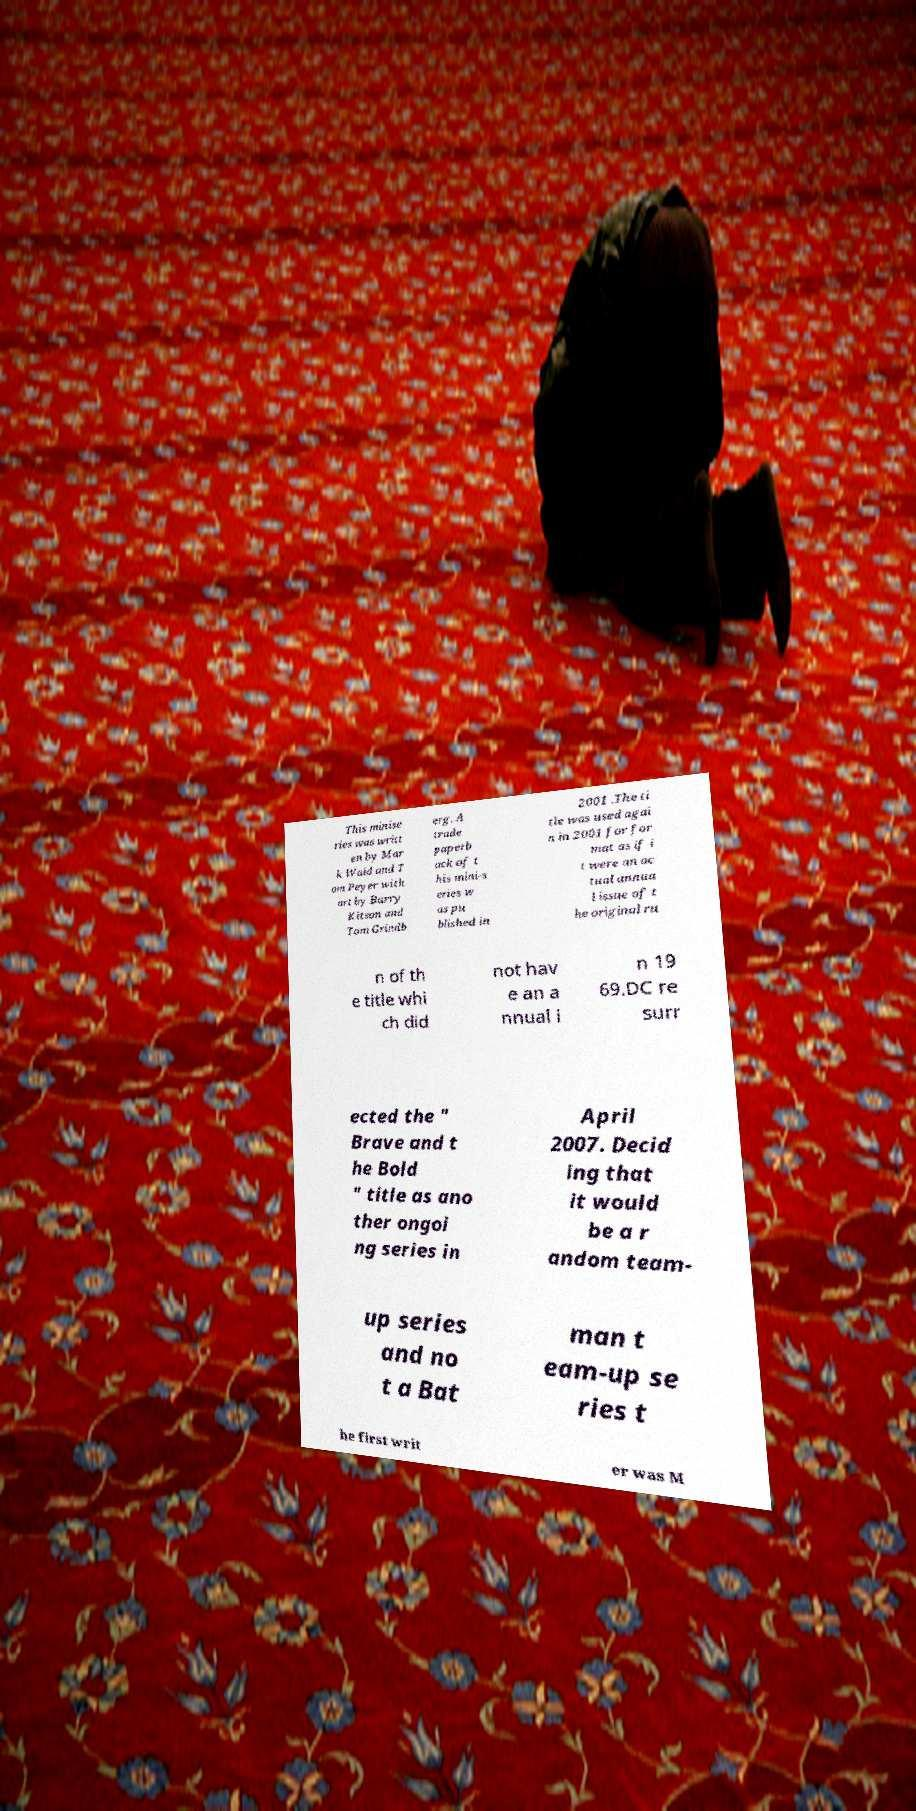Could you extract and type out the text from this image? This minise ries was writt en by Mar k Waid and T om Peyer with art by Barry Kitson and Tom Grindb erg. A trade paperb ack of t his mini-s eries w as pu blished in 2001 .The ti tle was used agai n in 2001 for for mat as if i t were an ac tual annua l issue of t he original ru n of th e title whi ch did not hav e an a nnual i n 19 69.DC re surr ected the " Brave and t he Bold " title as ano ther ongoi ng series in April 2007. Decid ing that it would be a r andom team- up series and no t a Bat man t eam-up se ries t he first writ er was M 